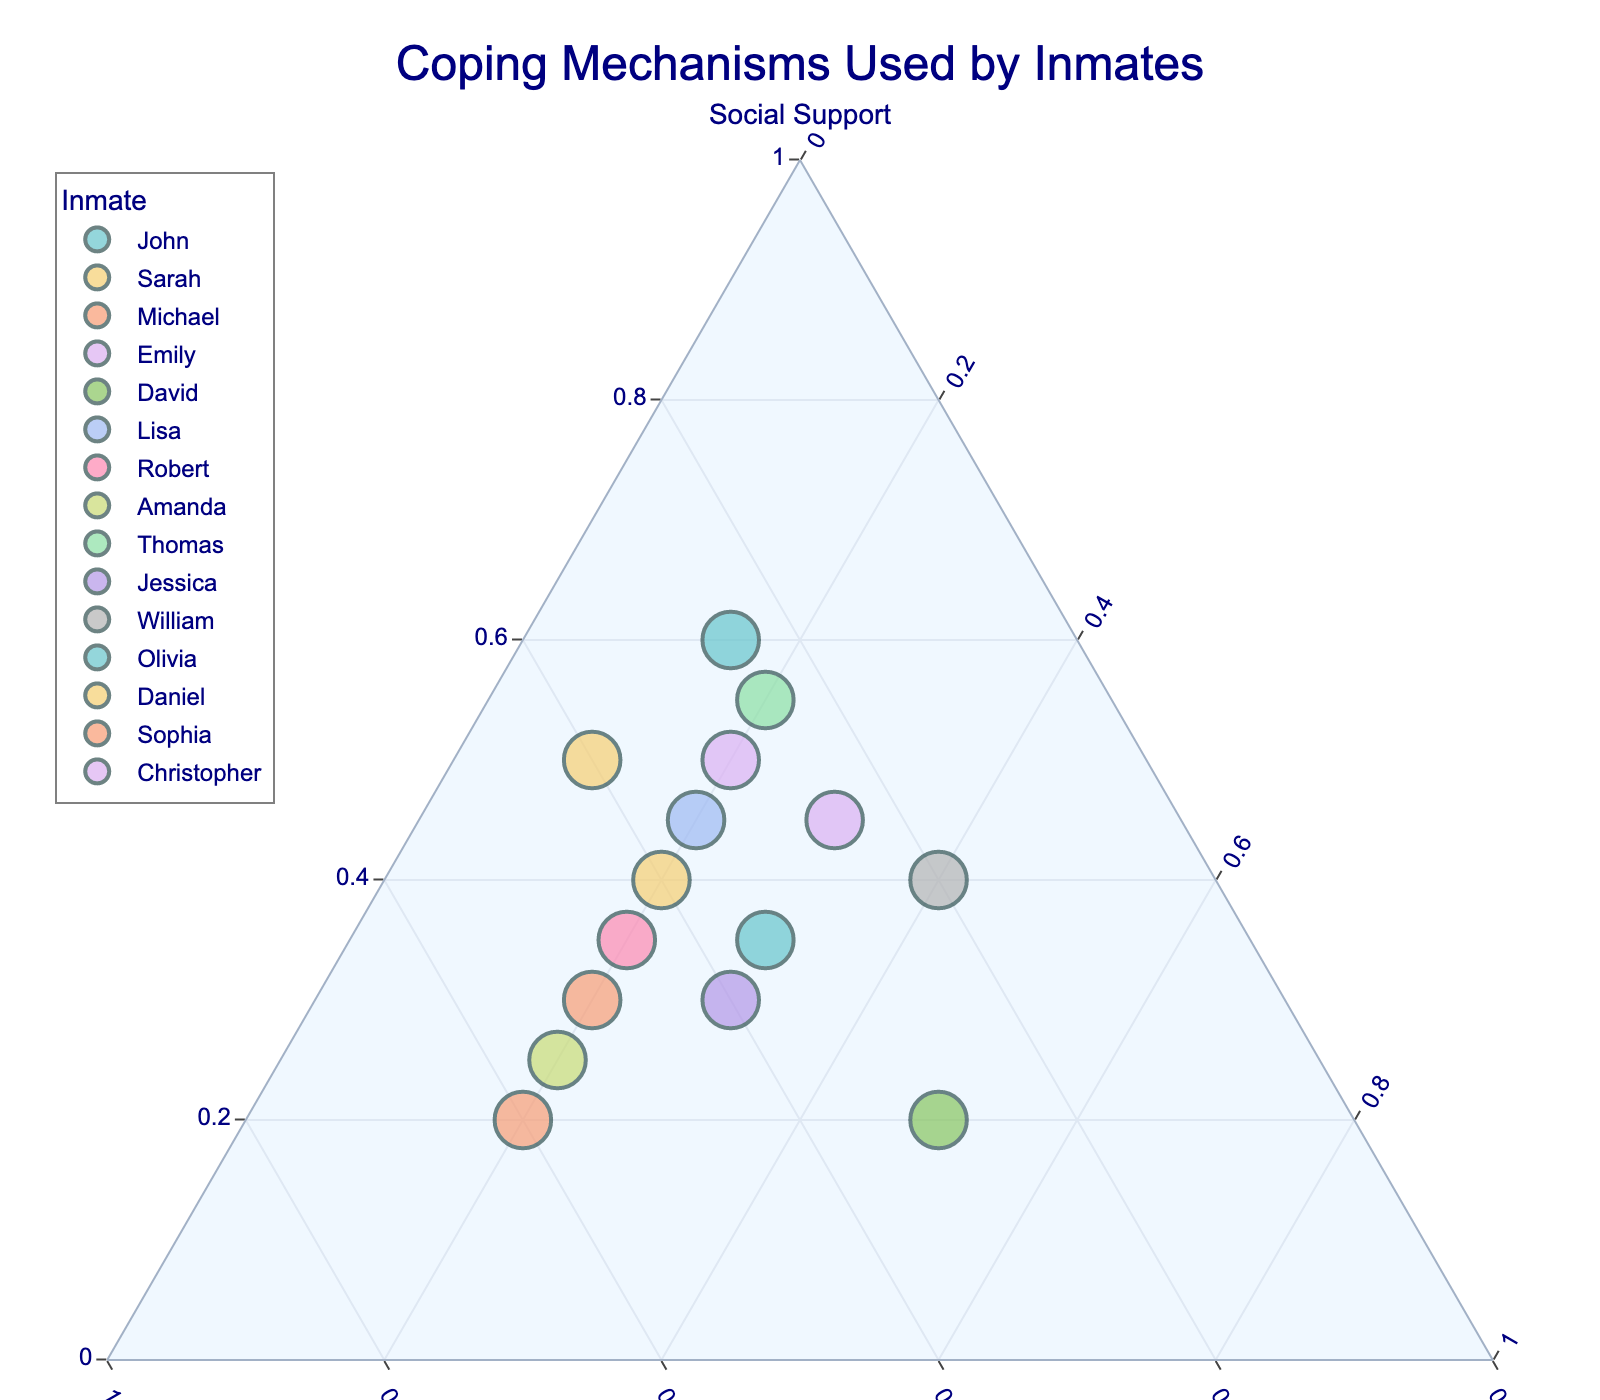What is the title of the plot? The title of the plot is placed at the top and is usually large and bold to be easily noticed. The title helps to understand the overall context of the plot.
Answer: Coping Mechanisms Used by Inmates What are the three coping mechanisms represented in the ternary plot? The three coping mechanisms are the labels of the axes, and they form the three vertices of the triangle in the ternary plot.
Answer: Social Support, Self-Reflection, Physical Activity Which inmate relies the most on Social Support? By looking at the vertex labeled "Social Support," you can find which point is closest to that vertex. The inmate closest to that vertex relies the most on Social Support.
Answer: John Who has the highest combination of Self-Reflection and Physical Activity? To determine this, find the data points that are closer to the Self-Reflection and Physical Activity vertices while being further away from the Social Support vertex.
Answer: David What is the median percentage of Self-Reflection used by the inmates? First, list the percentage of Self-Reflection for all inmates: [25, 40, 50, 30, 30, 35, 45, 55, 25, 40, 20, 35, 40, 60, 25], then order them: [20, 25, 25, 25, 30, 30, 35, 35, 40, 40, 40, 45, 50, 55, 60]. The median is the middle value.
Answer: 35 Who has a more balanced combination of all three coping mechanisms? Look for a data point situated more centrally within the triangle, implying a more uniform distribution of all three coping mechanisms.
Answer: Olivia How does Amanda's use of coping mechanisms compare to Sophia's? Examine both points on the ternary plot. Look at how Amanda and Sophia distribute their percentages among the three coping mechanisms and compare these distributions. Both have higher Self-Reflection, but Amanda has more Physical Activity, while Sophia has more Social Support.
Answer: Amanda has more Physical Activity and less Social Support compared to Sophia Which inmate combines the highest percentage of Social Support and Self-Reflection? Look for the point closest to the line connecting Social Support and Self-Reflection vertices and further from the Physical Activity vertex.
Answer: Thomas What is the average percentage of Physical Activity across all inmates? Find the percentages of Physical Activity: [15, 20, 20, 20, 50, 20, 20, 20, 20, 30, 40, 30, 10, 20, 30]. Sum them (15 + 20 + 20 + 20 + 50 + 20 + 20 + 20 + 20 + 30 + 40 + 30 + 10 + 20 + 30 = 385) and divide by the number of inmates (15).
Answer: 25.67 